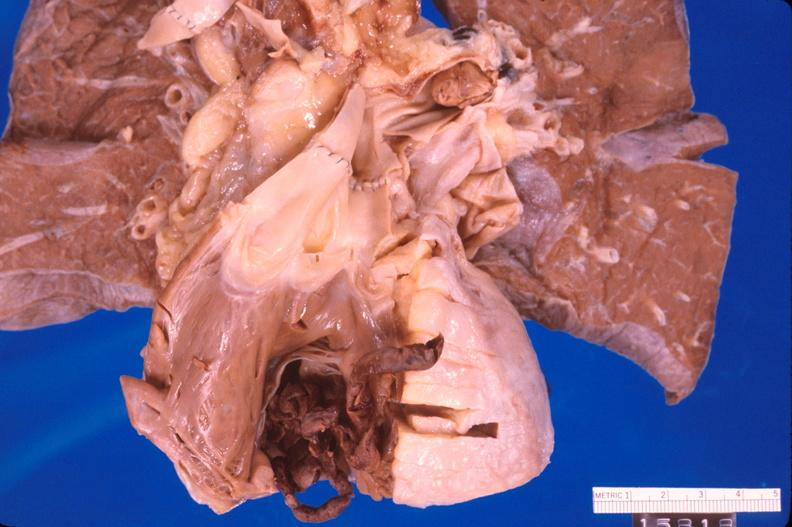s amyloidosis present?
Answer the question using a single word or phrase. No 